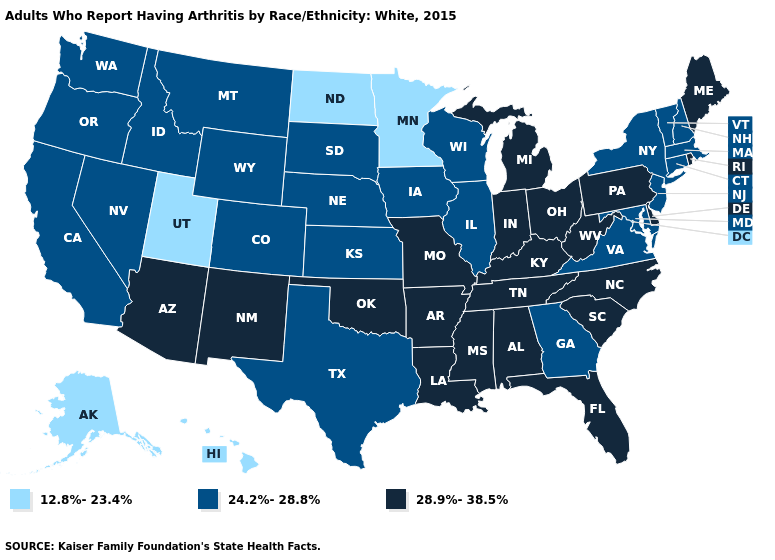Is the legend a continuous bar?
Be succinct. No. Name the states that have a value in the range 12.8%-23.4%?
Write a very short answer. Alaska, Hawaii, Minnesota, North Dakota, Utah. Name the states that have a value in the range 12.8%-23.4%?
Concise answer only. Alaska, Hawaii, Minnesota, North Dakota, Utah. What is the highest value in the South ?
Keep it brief. 28.9%-38.5%. What is the highest value in the USA?
Concise answer only. 28.9%-38.5%. What is the highest value in the USA?
Be succinct. 28.9%-38.5%. What is the value of South Dakota?
Write a very short answer. 24.2%-28.8%. Does the map have missing data?
Write a very short answer. No. Does Minnesota have the highest value in the MidWest?
Quick response, please. No. Among the states that border Louisiana , which have the highest value?
Be succinct. Arkansas, Mississippi. What is the value of Louisiana?
Answer briefly. 28.9%-38.5%. Name the states that have a value in the range 28.9%-38.5%?
Quick response, please. Alabama, Arizona, Arkansas, Delaware, Florida, Indiana, Kentucky, Louisiana, Maine, Michigan, Mississippi, Missouri, New Mexico, North Carolina, Ohio, Oklahoma, Pennsylvania, Rhode Island, South Carolina, Tennessee, West Virginia. Does New Jersey have the highest value in the Northeast?
Give a very brief answer. No. What is the value of Nevada?
Be succinct. 24.2%-28.8%. Does Texas have the lowest value in the South?
Be succinct. Yes. 